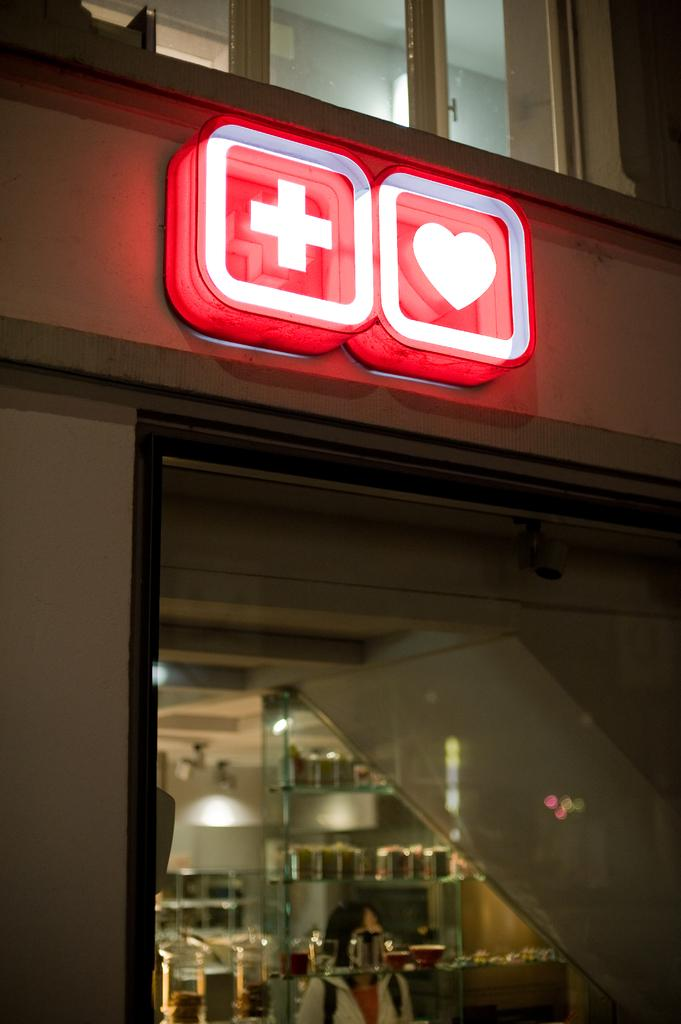What type of structure is visible in the image? There is a building in the image. What are some features of the building? The building has windows and sign boards. Can you describe what is inside the building? There are items inside the building, but the specifics are not mentioned in the facts. What type of print can be seen on the cast of the person in the image? There is no person or cast present in the image; it features a building with windows and sign boards. 